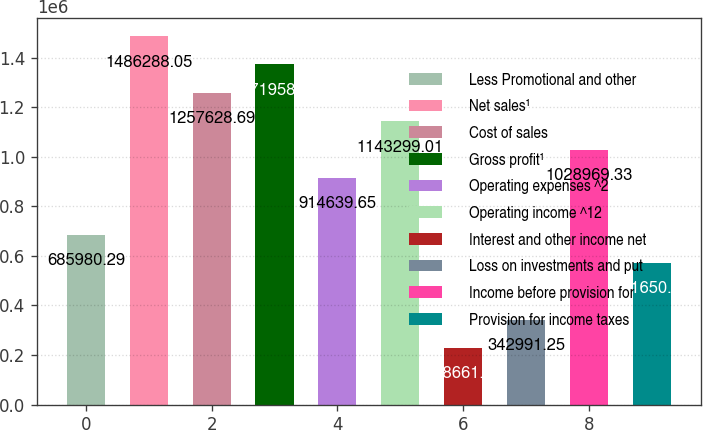Convert chart to OTSL. <chart><loc_0><loc_0><loc_500><loc_500><bar_chart><fcel>Less Promotional and other<fcel>Net sales¹<fcel>Cost of sales<fcel>Gross profit¹<fcel>Operating expenses ^2<fcel>Operating income ^12<fcel>Interest and other income net<fcel>Loss on investments and put<fcel>Income before provision for<fcel>Provision for income taxes<nl><fcel>685980<fcel>1.48629e+06<fcel>1.25763e+06<fcel>1.37196e+06<fcel>914640<fcel>1.1433e+06<fcel>228662<fcel>342991<fcel>1.02897e+06<fcel>571651<nl></chart> 